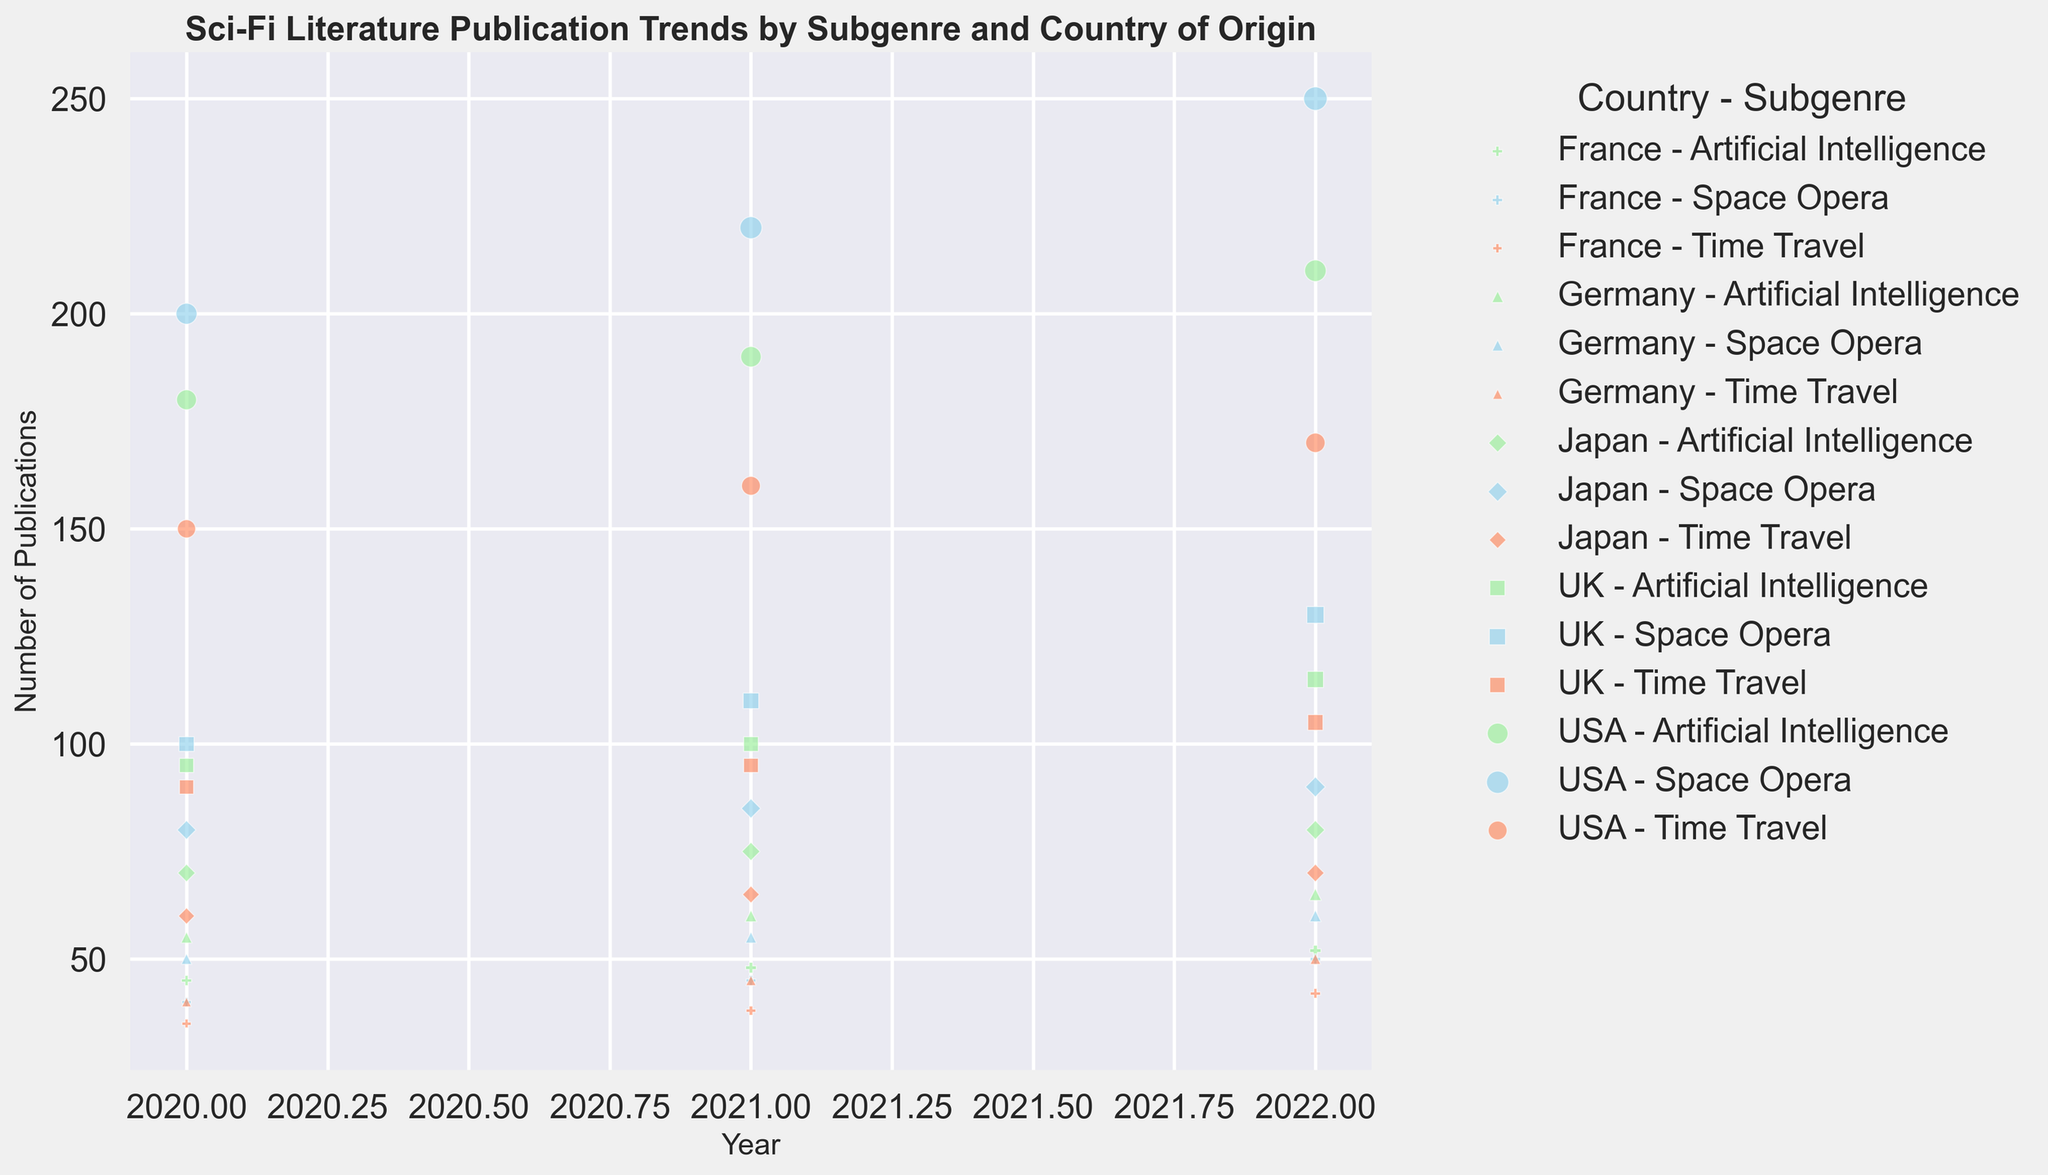Which country has the highest number of Space Opera publications in 2022? To find the country with the highest number of Space Opera publications in 2022, look for the bubbles at the year 2022 for Space Opera subgenre and compare their sizes. The USA has the largest bubble in 2022 for Space Opera.
Answer: USA How do the publication trends for the Time Travel subgenre compare between the USA and Japan from 2020 to 2022? Look for the Time Travel bubbles for both the USA and Japan from 2020 to 2022. The USA's bubbles grow from 150 to 170, while Japan’s bubbles grow from 60 to 70, showing the USA had a higher growth in Time Travel publications.
Answer: USA had greater growth What is the total number of Artificial Intelligence publications across all countries in 2022? Sum the Artificial Intelligence publication numbers for all countries in 2022: USA (210) + UK (115) + Japan (80) + Germany (65) + France (52). This gives 210 + 115 + 80 + 65 + 52 = 522.
Answer: 522 Which subgenre saw the highest growth in publication numbers in the UK from 2020 to 2022? Check the size of the bubbles for each subgenre in the UK from 2020 to 2022. Space Opera increased from 100 to 130, Time Travel from 90 to 105, and Artificial Intelligence from 95 to 115. The percentage growth: Space Opera (30%), Time Travel (16.67%), Artificial Intelligence (21.05%), showing the highest growth for Space Opera.
Answer: Space Opera Is the number of Space Opera publications in the UK in 2021 greater than the number of Artificial Intelligence publications in Germany in 2021? Compare the bubbles for the UK’s Space Opera in 2021 (110) and Germany’s Artificial Intelligence in 2021 (60). Since 110 > 60, UK’s Space Opera publications in 2021 are greater.
Answer: Yes 